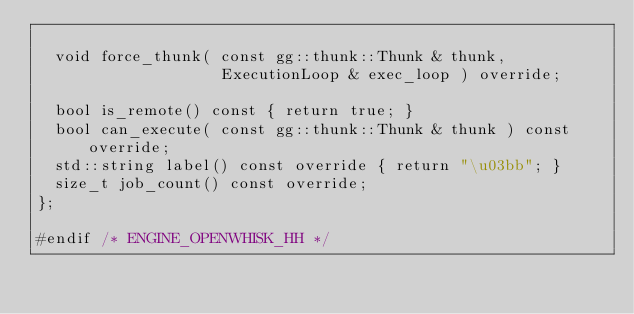Convert code to text. <code><loc_0><loc_0><loc_500><loc_500><_C++_>
  void force_thunk( const gg::thunk::Thunk & thunk,
                    ExecutionLoop & exec_loop ) override;

  bool is_remote() const { return true; }
  bool can_execute( const gg::thunk::Thunk & thunk ) const override;
  std::string label() const override { return "\u03bb"; }
  size_t job_count() const override;
};

#endif /* ENGINE_OPENWHISK_HH */
</code> 